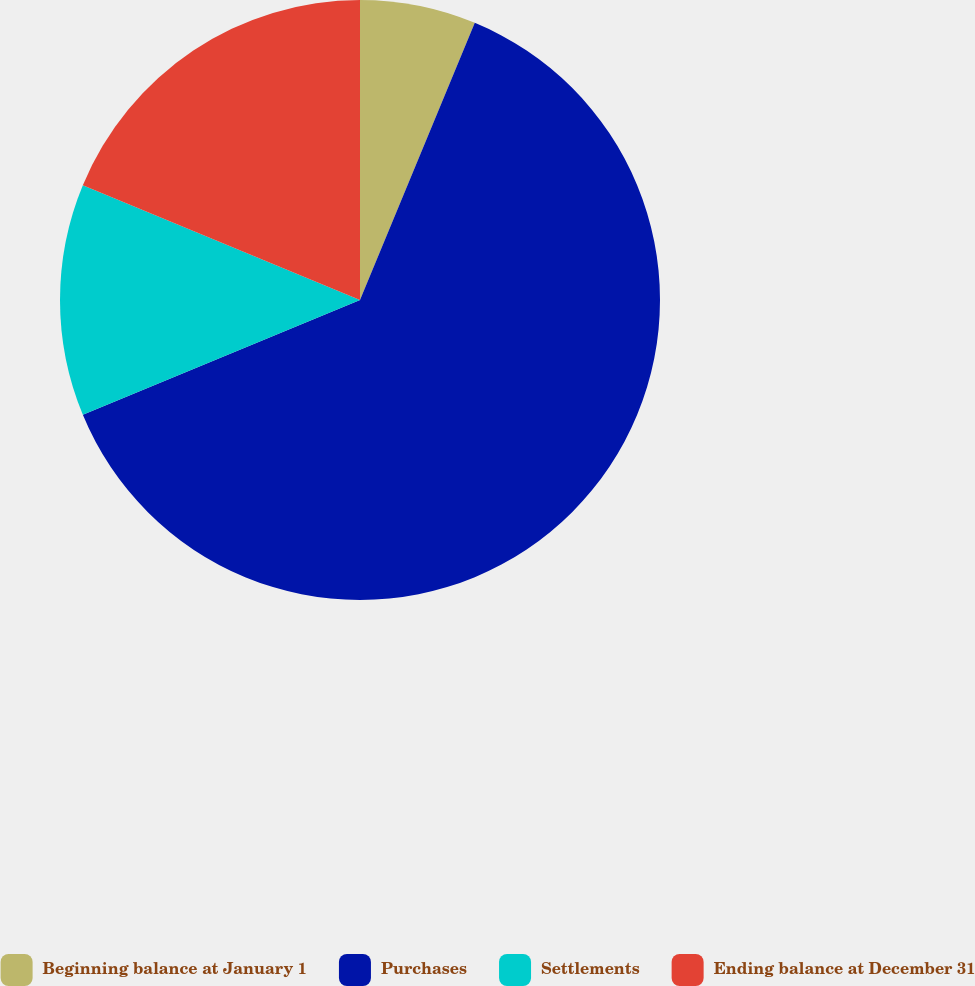Convert chart. <chart><loc_0><loc_0><loc_500><loc_500><pie_chart><fcel>Beginning balance at January 1<fcel>Purchases<fcel>Settlements<fcel>Ending balance at December 31<nl><fcel>6.25%<fcel>62.5%<fcel>12.5%<fcel>18.75%<nl></chart> 